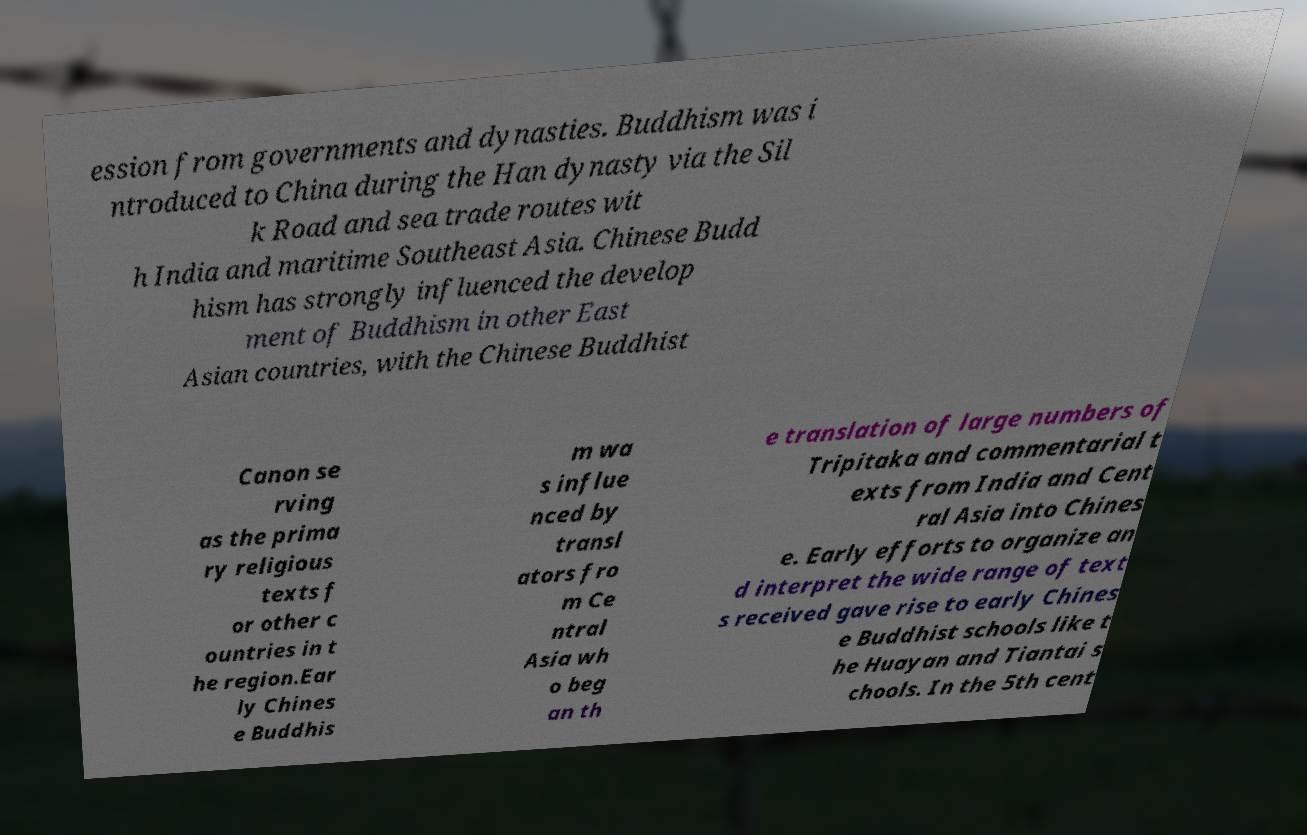I need the written content from this picture converted into text. Can you do that? ession from governments and dynasties. Buddhism was i ntroduced to China during the Han dynasty via the Sil k Road and sea trade routes wit h India and maritime Southeast Asia. Chinese Budd hism has strongly influenced the develop ment of Buddhism in other East Asian countries, with the Chinese Buddhist Canon se rving as the prima ry religious texts f or other c ountries in t he region.Ear ly Chines e Buddhis m wa s influe nced by transl ators fro m Ce ntral Asia wh o beg an th e translation of large numbers of Tripitaka and commentarial t exts from India and Cent ral Asia into Chines e. Early efforts to organize an d interpret the wide range of text s received gave rise to early Chines e Buddhist schools like t he Huayan and Tiantai s chools. In the 5th cent 